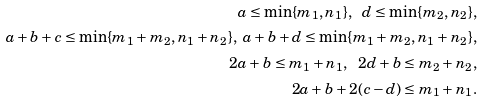<formula> <loc_0><loc_0><loc_500><loc_500>a \leq \min \{ m _ { 1 } , n _ { 1 } \} , \ d \leq \min \{ m _ { 2 } , n _ { 2 } \} , \\ a + b + c \leq \min \{ m _ { 1 } + m _ { 2 } , n _ { 1 } + n _ { 2 } \} , \ a + b + d \leq \min \{ m _ { 1 } + m _ { 2 } , n _ { 1 } + n _ { 2 } \} , \\ 2 a + b \leq m _ { 1 } + n _ { 1 } , \ \ 2 d + b \leq m _ { 2 } + n _ { 2 } , \\ 2 a + b + 2 ( c - d ) \leq m _ { 1 } + n _ { 1 } .</formula> 